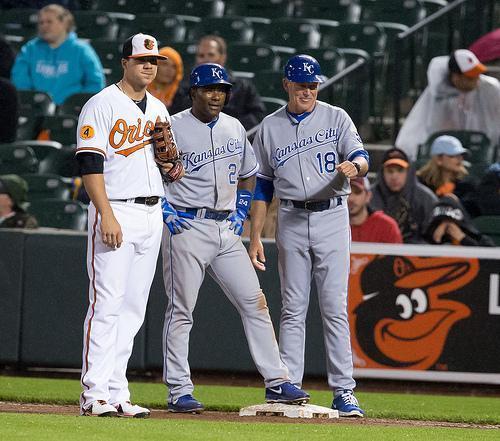How many people in the field?
Give a very brief answer. 3. 